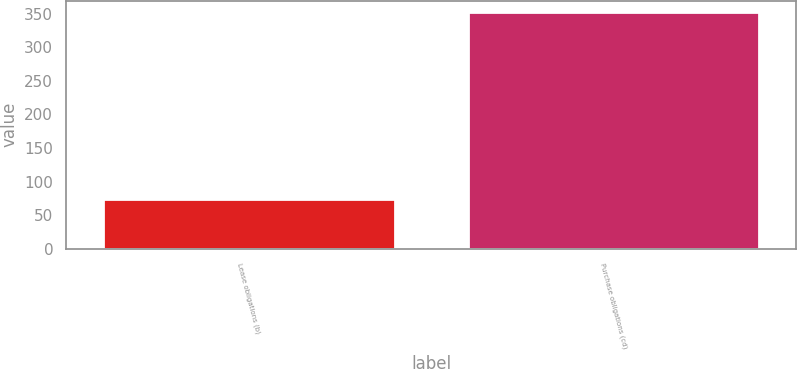Convert chart to OTSL. <chart><loc_0><loc_0><loc_500><loc_500><bar_chart><fcel>Lease obligations (b)<fcel>Purchase obligations (cd)<nl><fcel>74<fcel>352<nl></chart> 